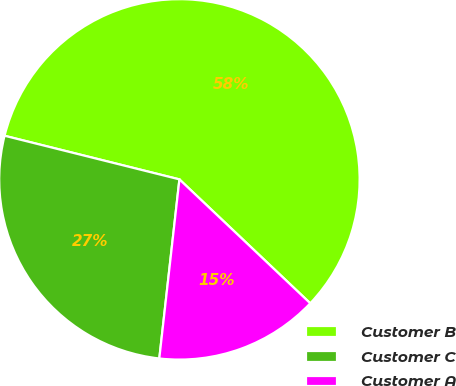<chart> <loc_0><loc_0><loc_500><loc_500><pie_chart><fcel>Customer B<fcel>Customer C<fcel>Customer A<nl><fcel>58.17%<fcel>27.11%<fcel>14.71%<nl></chart> 